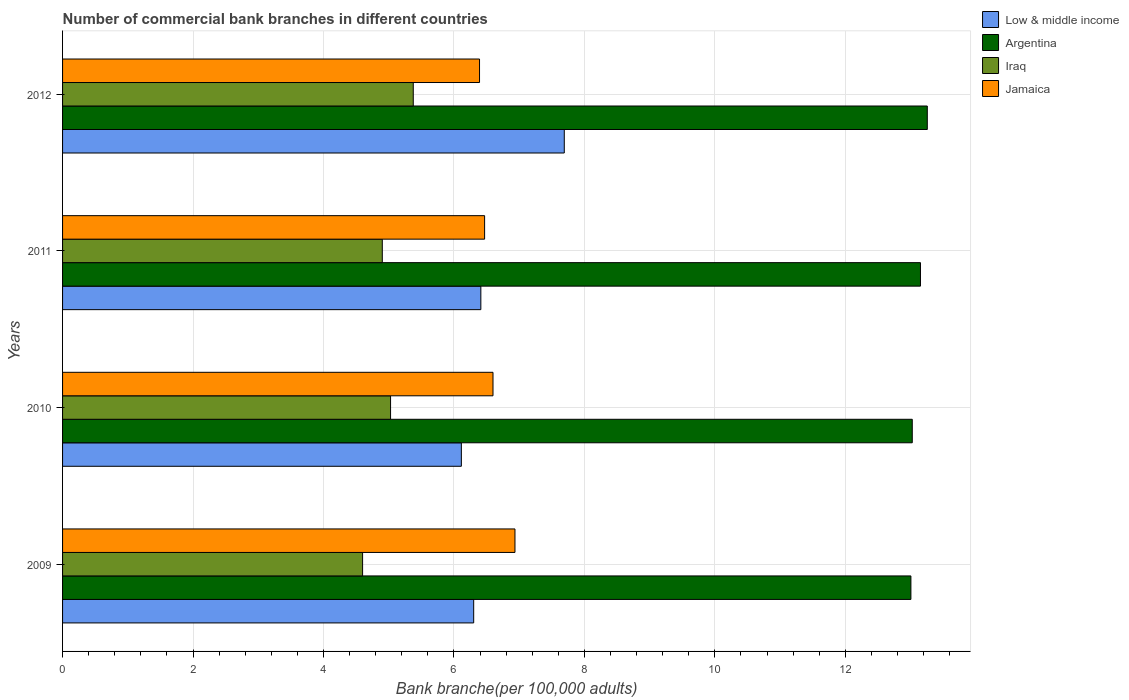How many bars are there on the 2nd tick from the top?
Your answer should be compact. 4. How many bars are there on the 2nd tick from the bottom?
Make the answer very short. 4. What is the label of the 4th group of bars from the top?
Offer a terse response. 2009. What is the number of commercial bank branches in Iraq in 2011?
Offer a very short reply. 4.9. Across all years, what is the maximum number of commercial bank branches in Jamaica?
Give a very brief answer. 6.94. Across all years, what is the minimum number of commercial bank branches in Jamaica?
Provide a succinct answer. 6.39. What is the total number of commercial bank branches in Jamaica in the graph?
Your response must be concise. 26.4. What is the difference between the number of commercial bank branches in Low & middle income in 2010 and that in 2011?
Keep it short and to the point. -0.3. What is the difference between the number of commercial bank branches in Jamaica in 2010 and the number of commercial bank branches in Argentina in 2012?
Your response must be concise. -6.66. What is the average number of commercial bank branches in Argentina per year?
Offer a very short reply. 13.11. In the year 2012, what is the difference between the number of commercial bank branches in Argentina and number of commercial bank branches in Iraq?
Provide a succinct answer. 7.88. What is the ratio of the number of commercial bank branches in Jamaica in 2009 to that in 2011?
Your answer should be very brief. 1.07. What is the difference between the highest and the second highest number of commercial bank branches in Jamaica?
Offer a very short reply. 0.34. What is the difference between the highest and the lowest number of commercial bank branches in Argentina?
Offer a terse response. 0.25. Is the sum of the number of commercial bank branches in Iraq in 2009 and 2012 greater than the maximum number of commercial bank branches in Low & middle income across all years?
Offer a terse response. Yes. Is it the case that in every year, the sum of the number of commercial bank branches in Jamaica and number of commercial bank branches in Iraq is greater than the sum of number of commercial bank branches in Argentina and number of commercial bank branches in Low & middle income?
Ensure brevity in your answer.  Yes. What does the 1st bar from the top in 2009 represents?
Provide a succinct answer. Jamaica. What does the 1st bar from the bottom in 2009 represents?
Make the answer very short. Low & middle income. Is it the case that in every year, the sum of the number of commercial bank branches in Low & middle income and number of commercial bank branches in Argentina is greater than the number of commercial bank branches in Iraq?
Offer a terse response. Yes. What is the difference between two consecutive major ticks on the X-axis?
Provide a succinct answer. 2. Are the values on the major ticks of X-axis written in scientific E-notation?
Give a very brief answer. No. How are the legend labels stacked?
Your answer should be compact. Vertical. What is the title of the graph?
Keep it short and to the point. Number of commercial bank branches in different countries. Does "Bolivia" appear as one of the legend labels in the graph?
Offer a terse response. No. What is the label or title of the X-axis?
Make the answer very short. Bank branche(per 100,0 adults). What is the label or title of the Y-axis?
Offer a very short reply. Years. What is the Bank branche(per 100,000 adults) in Low & middle income in 2009?
Provide a succinct answer. 6.3. What is the Bank branche(per 100,000 adults) in Argentina in 2009?
Your response must be concise. 13.01. What is the Bank branche(per 100,000 adults) of Iraq in 2009?
Provide a succinct answer. 4.6. What is the Bank branche(per 100,000 adults) of Jamaica in 2009?
Make the answer very short. 6.94. What is the Bank branche(per 100,000 adults) in Low & middle income in 2010?
Provide a short and direct response. 6.11. What is the Bank branche(per 100,000 adults) of Argentina in 2010?
Your answer should be very brief. 13.03. What is the Bank branche(per 100,000 adults) in Iraq in 2010?
Provide a succinct answer. 5.03. What is the Bank branche(per 100,000 adults) of Jamaica in 2010?
Your response must be concise. 6.6. What is the Bank branche(per 100,000 adults) in Low & middle income in 2011?
Ensure brevity in your answer.  6.41. What is the Bank branche(per 100,000 adults) of Argentina in 2011?
Your answer should be very brief. 13.15. What is the Bank branche(per 100,000 adults) in Iraq in 2011?
Offer a terse response. 4.9. What is the Bank branche(per 100,000 adults) of Jamaica in 2011?
Your answer should be compact. 6.47. What is the Bank branche(per 100,000 adults) in Low & middle income in 2012?
Your answer should be compact. 7.69. What is the Bank branche(per 100,000 adults) in Argentina in 2012?
Provide a succinct answer. 13.26. What is the Bank branche(per 100,000 adults) in Iraq in 2012?
Make the answer very short. 5.38. What is the Bank branche(per 100,000 adults) in Jamaica in 2012?
Your answer should be very brief. 6.39. Across all years, what is the maximum Bank branche(per 100,000 adults) of Low & middle income?
Your answer should be compact. 7.69. Across all years, what is the maximum Bank branche(per 100,000 adults) in Argentina?
Keep it short and to the point. 13.26. Across all years, what is the maximum Bank branche(per 100,000 adults) of Iraq?
Ensure brevity in your answer.  5.38. Across all years, what is the maximum Bank branche(per 100,000 adults) in Jamaica?
Keep it short and to the point. 6.94. Across all years, what is the minimum Bank branche(per 100,000 adults) in Low & middle income?
Give a very brief answer. 6.11. Across all years, what is the minimum Bank branche(per 100,000 adults) of Argentina?
Your response must be concise. 13.01. Across all years, what is the minimum Bank branche(per 100,000 adults) of Iraq?
Provide a succinct answer. 4.6. Across all years, what is the minimum Bank branche(per 100,000 adults) of Jamaica?
Your response must be concise. 6.39. What is the total Bank branche(per 100,000 adults) in Low & middle income in the graph?
Make the answer very short. 26.52. What is the total Bank branche(per 100,000 adults) in Argentina in the graph?
Offer a terse response. 52.44. What is the total Bank branche(per 100,000 adults) of Iraq in the graph?
Your response must be concise. 19.91. What is the total Bank branche(per 100,000 adults) of Jamaica in the graph?
Your answer should be compact. 26.4. What is the difference between the Bank branche(per 100,000 adults) in Low & middle income in 2009 and that in 2010?
Your answer should be compact. 0.19. What is the difference between the Bank branche(per 100,000 adults) in Argentina in 2009 and that in 2010?
Your answer should be compact. -0.02. What is the difference between the Bank branche(per 100,000 adults) in Iraq in 2009 and that in 2010?
Give a very brief answer. -0.43. What is the difference between the Bank branche(per 100,000 adults) in Jamaica in 2009 and that in 2010?
Offer a terse response. 0.34. What is the difference between the Bank branche(per 100,000 adults) of Low & middle income in 2009 and that in 2011?
Make the answer very short. -0.11. What is the difference between the Bank branche(per 100,000 adults) in Argentina in 2009 and that in 2011?
Keep it short and to the point. -0.15. What is the difference between the Bank branche(per 100,000 adults) of Iraq in 2009 and that in 2011?
Give a very brief answer. -0.3. What is the difference between the Bank branche(per 100,000 adults) of Jamaica in 2009 and that in 2011?
Provide a succinct answer. 0.47. What is the difference between the Bank branche(per 100,000 adults) in Low & middle income in 2009 and that in 2012?
Your response must be concise. -1.39. What is the difference between the Bank branche(per 100,000 adults) in Argentina in 2009 and that in 2012?
Offer a very short reply. -0.25. What is the difference between the Bank branche(per 100,000 adults) of Iraq in 2009 and that in 2012?
Ensure brevity in your answer.  -0.78. What is the difference between the Bank branche(per 100,000 adults) in Jamaica in 2009 and that in 2012?
Offer a terse response. 0.54. What is the difference between the Bank branche(per 100,000 adults) of Low & middle income in 2010 and that in 2011?
Ensure brevity in your answer.  -0.3. What is the difference between the Bank branche(per 100,000 adults) in Argentina in 2010 and that in 2011?
Offer a very short reply. -0.13. What is the difference between the Bank branche(per 100,000 adults) in Iraq in 2010 and that in 2011?
Offer a terse response. 0.13. What is the difference between the Bank branche(per 100,000 adults) of Jamaica in 2010 and that in 2011?
Make the answer very short. 0.13. What is the difference between the Bank branche(per 100,000 adults) of Low & middle income in 2010 and that in 2012?
Provide a short and direct response. -1.58. What is the difference between the Bank branche(per 100,000 adults) in Argentina in 2010 and that in 2012?
Give a very brief answer. -0.23. What is the difference between the Bank branche(per 100,000 adults) of Iraq in 2010 and that in 2012?
Make the answer very short. -0.35. What is the difference between the Bank branche(per 100,000 adults) of Jamaica in 2010 and that in 2012?
Ensure brevity in your answer.  0.21. What is the difference between the Bank branche(per 100,000 adults) in Low & middle income in 2011 and that in 2012?
Ensure brevity in your answer.  -1.28. What is the difference between the Bank branche(per 100,000 adults) in Argentina in 2011 and that in 2012?
Offer a terse response. -0.1. What is the difference between the Bank branche(per 100,000 adults) in Iraq in 2011 and that in 2012?
Provide a short and direct response. -0.47. What is the difference between the Bank branche(per 100,000 adults) in Jamaica in 2011 and that in 2012?
Provide a succinct answer. 0.08. What is the difference between the Bank branche(per 100,000 adults) of Low & middle income in 2009 and the Bank branche(per 100,000 adults) of Argentina in 2010?
Make the answer very short. -6.72. What is the difference between the Bank branche(per 100,000 adults) of Low & middle income in 2009 and the Bank branche(per 100,000 adults) of Iraq in 2010?
Keep it short and to the point. 1.27. What is the difference between the Bank branche(per 100,000 adults) in Low & middle income in 2009 and the Bank branche(per 100,000 adults) in Jamaica in 2010?
Your response must be concise. -0.3. What is the difference between the Bank branche(per 100,000 adults) in Argentina in 2009 and the Bank branche(per 100,000 adults) in Iraq in 2010?
Your response must be concise. 7.98. What is the difference between the Bank branche(per 100,000 adults) of Argentina in 2009 and the Bank branche(per 100,000 adults) of Jamaica in 2010?
Your response must be concise. 6.41. What is the difference between the Bank branche(per 100,000 adults) in Iraq in 2009 and the Bank branche(per 100,000 adults) in Jamaica in 2010?
Your response must be concise. -2. What is the difference between the Bank branche(per 100,000 adults) in Low & middle income in 2009 and the Bank branche(per 100,000 adults) in Argentina in 2011?
Give a very brief answer. -6.85. What is the difference between the Bank branche(per 100,000 adults) of Low & middle income in 2009 and the Bank branche(per 100,000 adults) of Iraq in 2011?
Your answer should be compact. 1.4. What is the difference between the Bank branche(per 100,000 adults) of Low & middle income in 2009 and the Bank branche(per 100,000 adults) of Jamaica in 2011?
Your response must be concise. -0.17. What is the difference between the Bank branche(per 100,000 adults) of Argentina in 2009 and the Bank branche(per 100,000 adults) of Iraq in 2011?
Your answer should be very brief. 8.1. What is the difference between the Bank branche(per 100,000 adults) in Argentina in 2009 and the Bank branche(per 100,000 adults) in Jamaica in 2011?
Your answer should be very brief. 6.54. What is the difference between the Bank branche(per 100,000 adults) in Iraq in 2009 and the Bank branche(per 100,000 adults) in Jamaica in 2011?
Give a very brief answer. -1.87. What is the difference between the Bank branche(per 100,000 adults) of Low & middle income in 2009 and the Bank branche(per 100,000 adults) of Argentina in 2012?
Provide a short and direct response. -6.95. What is the difference between the Bank branche(per 100,000 adults) in Low & middle income in 2009 and the Bank branche(per 100,000 adults) in Iraq in 2012?
Offer a terse response. 0.93. What is the difference between the Bank branche(per 100,000 adults) of Low & middle income in 2009 and the Bank branche(per 100,000 adults) of Jamaica in 2012?
Your answer should be compact. -0.09. What is the difference between the Bank branche(per 100,000 adults) in Argentina in 2009 and the Bank branche(per 100,000 adults) in Iraq in 2012?
Offer a terse response. 7.63. What is the difference between the Bank branche(per 100,000 adults) of Argentina in 2009 and the Bank branche(per 100,000 adults) of Jamaica in 2012?
Keep it short and to the point. 6.61. What is the difference between the Bank branche(per 100,000 adults) of Iraq in 2009 and the Bank branche(per 100,000 adults) of Jamaica in 2012?
Give a very brief answer. -1.79. What is the difference between the Bank branche(per 100,000 adults) in Low & middle income in 2010 and the Bank branche(per 100,000 adults) in Argentina in 2011?
Provide a short and direct response. -7.04. What is the difference between the Bank branche(per 100,000 adults) in Low & middle income in 2010 and the Bank branche(per 100,000 adults) in Iraq in 2011?
Offer a terse response. 1.21. What is the difference between the Bank branche(per 100,000 adults) of Low & middle income in 2010 and the Bank branche(per 100,000 adults) of Jamaica in 2011?
Make the answer very short. -0.36. What is the difference between the Bank branche(per 100,000 adults) of Argentina in 2010 and the Bank branche(per 100,000 adults) of Iraq in 2011?
Provide a succinct answer. 8.12. What is the difference between the Bank branche(per 100,000 adults) in Argentina in 2010 and the Bank branche(per 100,000 adults) in Jamaica in 2011?
Your answer should be compact. 6.56. What is the difference between the Bank branche(per 100,000 adults) of Iraq in 2010 and the Bank branche(per 100,000 adults) of Jamaica in 2011?
Your answer should be very brief. -1.44. What is the difference between the Bank branche(per 100,000 adults) in Low & middle income in 2010 and the Bank branche(per 100,000 adults) in Argentina in 2012?
Provide a short and direct response. -7.14. What is the difference between the Bank branche(per 100,000 adults) in Low & middle income in 2010 and the Bank branche(per 100,000 adults) in Iraq in 2012?
Your answer should be very brief. 0.74. What is the difference between the Bank branche(per 100,000 adults) of Low & middle income in 2010 and the Bank branche(per 100,000 adults) of Jamaica in 2012?
Make the answer very short. -0.28. What is the difference between the Bank branche(per 100,000 adults) of Argentina in 2010 and the Bank branche(per 100,000 adults) of Iraq in 2012?
Provide a succinct answer. 7.65. What is the difference between the Bank branche(per 100,000 adults) of Argentina in 2010 and the Bank branche(per 100,000 adults) of Jamaica in 2012?
Your answer should be compact. 6.63. What is the difference between the Bank branche(per 100,000 adults) of Iraq in 2010 and the Bank branche(per 100,000 adults) of Jamaica in 2012?
Your response must be concise. -1.36. What is the difference between the Bank branche(per 100,000 adults) of Low & middle income in 2011 and the Bank branche(per 100,000 adults) of Argentina in 2012?
Your answer should be compact. -6.84. What is the difference between the Bank branche(per 100,000 adults) in Low & middle income in 2011 and the Bank branche(per 100,000 adults) in Iraq in 2012?
Provide a short and direct response. 1.04. What is the difference between the Bank branche(per 100,000 adults) of Low & middle income in 2011 and the Bank branche(per 100,000 adults) of Jamaica in 2012?
Your answer should be very brief. 0.02. What is the difference between the Bank branche(per 100,000 adults) of Argentina in 2011 and the Bank branche(per 100,000 adults) of Iraq in 2012?
Make the answer very short. 7.78. What is the difference between the Bank branche(per 100,000 adults) in Argentina in 2011 and the Bank branche(per 100,000 adults) in Jamaica in 2012?
Offer a very short reply. 6.76. What is the difference between the Bank branche(per 100,000 adults) of Iraq in 2011 and the Bank branche(per 100,000 adults) of Jamaica in 2012?
Make the answer very short. -1.49. What is the average Bank branche(per 100,000 adults) of Low & middle income per year?
Provide a succinct answer. 6.63. What is the average Bank branche(per 100,000 adults) in Argentina per year?
Make the answer very short. 13.11. What is the average Bank branche(per 100,000 adults) of Iraq per year?
Keep it short and to the point. 4.98. What is the average Bank branche(per 100,000 adults) in Jamaica per year?
Keep it short and to the point. 6.6. In the year 2009, what is the difference between the Bank branche(per 100,000 adults) in Low & middle income and Bank branche(per 100,000 adults) in Argentina?
Ensure brevity in your answer.  -6.7. In the year 2009, what is the difference between the Bank branche(per 100,000 adults) of Low & middle income and Bank branche(per 100,000 adults) of Iraq?
Keep it short and to the point. 1.7. In the year 2009, what is the difference between the Bank branche(per 100,000 adults) in Low & middle income and Bank branche(per 100,000 adults) in Jamaica?
Offer a terse response. -0.63. In the year 2009, what is the difference between the Bank branche(per 100,000 adults) in Argentina and Bank branche(per 100,000 adults) in Iraq?
Provide a succinct answer. 8.41. In the year 2009, what is the difference between the Bank branche(per 100,000 adults) in Argentina and Bank branche(per 100,000 adults) in Jamaica?
Keep it short and to the point. 6.07. In the year 2009, what is the difference between the Bank branche(per 100,000 adults) of Iraq and Bank branche(per 100,000 adults) of Jamaica?
Make the answer very short. -2.34. In the year 2010, what is the difference between the Bank branche(per 100,000 adults) of Low & middle income and Bank branche(per 100,000 adults) of Argentina?
Provide a short and direct response. -6.91. In the year 2010, what is the difference between the Bank branche(per 100,000 adults) of Low & middle income and Bank branche(per 100,000 adults) of Iraq?
Ensure brevity in your answer.  1.09. In the year 2010, what is the difference between the Bank branche(per 100,000 adults) in Low & middle income and Bank branche(per 100,000 adults) in Jamaica?
Make the answer very short. -0.48. In the year 2010, what is the difference between the Bank branche(per 100,000 adults) in Argentina and Bank branche(per 100,000 adults) in Iraq?
Offer a very short reply. 8. In the year 2010, what is the difference between the Bank branche(per 100,000 adults) of Argentina and Bank branche(per 100,000 adults) of Jamaica?
Your answer should be very brief. 6.43. In the year 2010, what is the difference between the Bank branche(per 100,000 adults) of Iraq and Bank branche(per 100,000 adults) of Jamaica?
Make the answer very short. -1.57. In the year 2011, what is the difference between the Bank branche(per 100,000 adults) in Low & middle income and Bank branche(per 100,000 adults) in Argentina?
Make the answer very short. -6.74. In the year 2011, what is the difference between the Bank branche(per 100,000 adults) in Low & middle income and Bank branche(per 100,000 adults) in Iraq?
Ensure brevity in your answer.  1.51. In the year 2011, what is the difference between the Bank branche(per 100,000 adults) in Low & middle income and Bank branche(per 100,000 adults) in Jamaica?
Ensure brevity in your answer.  -0.06. In the year 2011, what is the difference between the Bank branche(per 100,000 adults) in Argentina and Bank branche(per 100,000 adults) in Iraq?
Offer a very short reply. 8.25. In the year 2011, what is the difference between the Bank branche(per 100,000 adults) in Argentina and Bank branche(per 100,000 adults) in Jamaica?
Make the answer very short. 6.68. In the year 2011, what is the difference between the Bank branche(per 100,000 adults) in Iraq and Bank branche(per 100,000 adults) in Jamaica?
Make the answer very short. -1.57. In the year 2012, what is the difference between the Bank branche(per 100,000 adults) in Low & middle income and Bank branche(per 100,000 adults) in Argentina?
Provide a short and direct response. -5.57. In the year 2012, what is the difference between the Bank branche(per 100,000 adults) in Low & middle income and Bank branche(per 100,000 adults) in Iraq?
Offer a very short reply. 2.32. In the year 2012, what is the difference between the Bank branche(per 100,000 adults) of Low & middle income and Bank branche(per 100,000 adults) of Jamaica?
Offer a terse response. 1.3. In the year 2012, what is the difference between the Bank branche(per 100,000 adults) in Argentina and Bank branche(per 100,000 adults) in Iraq?
Offer a terse response. 7.88. In the year 2012, what is the difference between the Bank branche(per 100,000 adults) of Argentina and Bank branche(per 100,000 adults) of Jamaica?
Offer a terse response. 6.86. In the year 2012, what is the difference between the Bank branche(per 100,000 adults) in Iraq and Bank branche(per 100,000 adults) in Jamaica?
Provide a short and direct response. -1.02. What is the ratio of the Bank branche(per 100,000 adults) in Low & middle income in 2009 to that in 2010?
Offer a terse response. 1.03. What is the ratio of the Bank branche(per 100,000 adults) of Iraq in 2009 to that in 2010?
Your answer should be very brief. 0.91. What is the ratio of the Bank branche(per 100,000 adults) in Jamaica in 2009 to that in 2010?
Provide a short and direct response. 1.05. What is the ratio of the Bank branche(per 100,000 adults) in Low & middle income in 2009 to that in 2011?
Give a very brief answer. 0.98. What is the ratio of the Bank branche(per 100,000 adults) of Argentina in 2009 to that in 2011?
Give a very brief answer. 0.99. What is the ratio of the Bank branche(per 100,000 adults) in Iraq in 2009 to that in 2011?
Your response must be concise. 0.94. What is the ratio of the Bank branche(per 100,000 adults) of Jamaica in 2009 to that in 2011?
Provide a short and direct response. 1.07. What is the ratio of the Bank branche(per 100,000 adults) of Low & middle income in 2009 to that in 2012?
Offer a very short reply. 0.82. What is the ratio of the Bank branche(per 100,000 adults) in Argentina in 2009 to that in 2012?
Make the answer very short. 0.98. What is the ratio of the Bank branche(per 100,000 adults) in Iraq in 2009 to that in 2012?
Keep it short and to the point. 0.86. What is the ratio of the Bank branche(per 100,000 adults) of Jamaica in 2009 to that in 2012?
Provide a succinct answer. 1.08. What is the ratio of the Bank branche(per 100,000 adults) in Low & middle income in 2010 to that in 2011?
Provide a succinct answer. 0.95. What is the ratio of the Bank branche(per 100,000 adults) of Argentina in 2010 to that in 2011?
Offer a very short reply. 0.99. What is the ratio of the Bank branche(per 100,000 adults) in Iraq in 2010 to that in 2011?
Provide a short and direct response. 1.03. What is the ratio of the Bank branche(per 100,000 adults) of Jamaica in 2010 to that in 2011?
Your answer should be compact. 1.02. What is the ratio of the Bank branche(per 100,000 adults) in Low & middle income in 2010 to that in 2012?
Offer a very short reply. 0.79. What is the ratio of the Bank branche(per 100,000 adults) of Argentina in 2010 to that in 2012?
Your answer should be very brief. 0.98. What is the ratio of the Bank branche(per 100,000 adults) in Iraq in 2010 to that in 2012?
Ensure brevity in your answer.  0.94. What is the ratio of the Bank branche(per 100,000 adults) in Jamaica in 2010 to that in 2012?
Keep it short and to the point. 1.03. What is the ratio of the Bank branche(per 100,000 adults) of Low & middle income in 2011 to that in 2012?
Your answer should be compact. 0.83. What is the ratio of the Bank branche(per 100,000 adults) in Argentina in 2011 to that in 2012?
Offer a very short reply. 0.99. What is the ratio of the Bank branche(per 100,000 adults) of Iraq in 2011 to that in 2012?
Ensure brevity in your answer.  0.91. What is the ratio of the Bank branche(per 100,000 adults) of Jamaica in 2011 to that in 2012?
Provide a short and direct response. 1.01. What is the difference between the highest and the second highest Bank branche(per 100,000 adults) in Low & middle income?
Keep it short and to the point. 1.28. What is the difference between the highest and the second highest Bank branche(per 100,000 adults) of Argentina?
Ensure brevity in your answer.  0.1. What is the difference between the highest and the second highest Bank branche(per 100,000 adults) of Iraq?
Give a very brief answer. 0.35. What is the difference between the highest and the second highest Bank branche(per 100,000 adults) of Jamaica?
Ensure brevity in your answer.  0.34. What is the difference between the highest and the lowest Bank branche(per 100,000 adults) of Low & middle income?
Your answer should be very brief. 1.58. What is the difference between the highest and the lowest Bank branche(per 100,000 adults) in Argentina?
Your answer should be compact. 0.25. What is the difference between the highest and the lowest Bank branche(per 100,000 adults) in Iraq?
Keep it short and to the point. 0.78. What is the difference between the highest and the lowest Bank branche(per 100,000 adults) in Jamaica?
Provide a short and direct response. 0.54. 